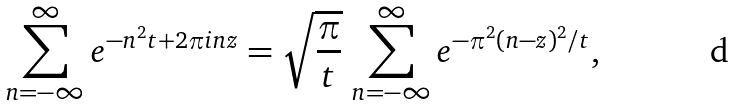Convert formula to latex. <formula><loc_0><loc_0><loc_500><loc_500>\sum _ { n = - \infty } ^ { \infty } e ^ { - n ^ { 2 } t + 2 \pi i n z } = \sqrt { \frac { \pi } { t } } \, \sum _ { n = - \infty } ^ { \infty } e ^ { - \pi ^ { 2 } ( n - z ) ^ { 2 } / t } ,</formula> 